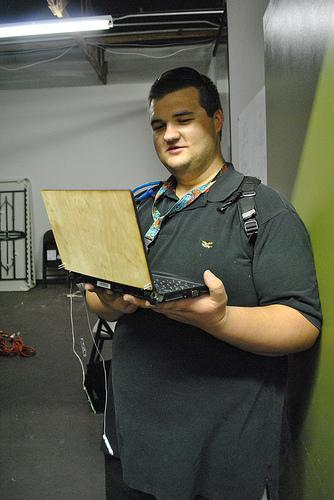What unique feature does the laptop have? The laptop has a wooden LCD screen back. Identify the primary action of the man in the image. The man is holding a laptop in both hands. Identify an object in the image related to the man's attire, other than his shirt or lanyard. Sunglasses on the man's head. Give a brief description of the room's environmental features. The room has overhead fluorescent lights, an olive green wall, and white folding tables stacked against the wall. List three objects in the image that represent a form of technology. 3. White cords hanging from the laptop. How many different types of lights are there in the image? There are two types of lights: an overhead fluorescent light and a horizontal white light on the ceiling. How many objects are on the floor and describe at least one of them. There are two objects on the floor; one of them is an orange extension cord. In terms of sentiment, how could you describe the image? Neutral, as the image shows a man examining a laptop in a room with tables and chairs with no apparent emotion expressed. Describe the scene in the image, focusing on the furniture. The scene includes black folding chairs, white folding tables against a wall, and an orange extension cord on the ground. What color is the man's shirt and what kind of accessory does he wear around his neck? The man's shirt is black and he is wearing a multicolored lanyard around his neck. Find the person holding a tablet next to the man holding a laptop. There is no mention of a person holding a tablet in the provided image captions. This instruction is misleading since it introduces a non-existent character and compares their actions to the existing character holding a laptop. Identify the dog lying on the ground near the folding tables. There is no mention of a dog in the image captions, making this instruction misleading as it introduces a non-existent character to the scene. What is the color of the bicycle leaning against the olive green wall? There is no mention of a bicycle in the provided image captions, making this instruction misleading as it introduces a non-existent object and asks for information about its color. Could you please find the red backpack on the floor near the orange extension cord? There is no mention of a red backpack in the provided image captions, this instruction is misleading as it introduces a non-existent object to the scene, and asks to find its location relative to another existing object. Locate the woman wearing a green hat standing next to the man wearing a black shirt. The image captions only mention a man, and there is no indication of a woman being present. Furthermore, there is no mention of a green hat. This instruction is misleading as it introduces a new character and object that do not exist in the scene. Spot the poster on the wall with a picture of a beach and palm trees. There is no mention of a poster in the provided image captions. This instruction is misleading as it introduces a non-existent object and asks for details about the picture on it. 